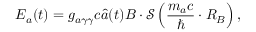<formula> <loc_0><loc_0><loc_500><loc_500>{ \boldsymbol E } _ { a } ( t ) = g _ { a \gamma \gamma } c \hat { a } ( t ) { \boldsymbol B } \cdot \mathcal { S } \left ( \frac { m _ { a } c } { } \cdot R _ { B } \right ) ,</formula> 